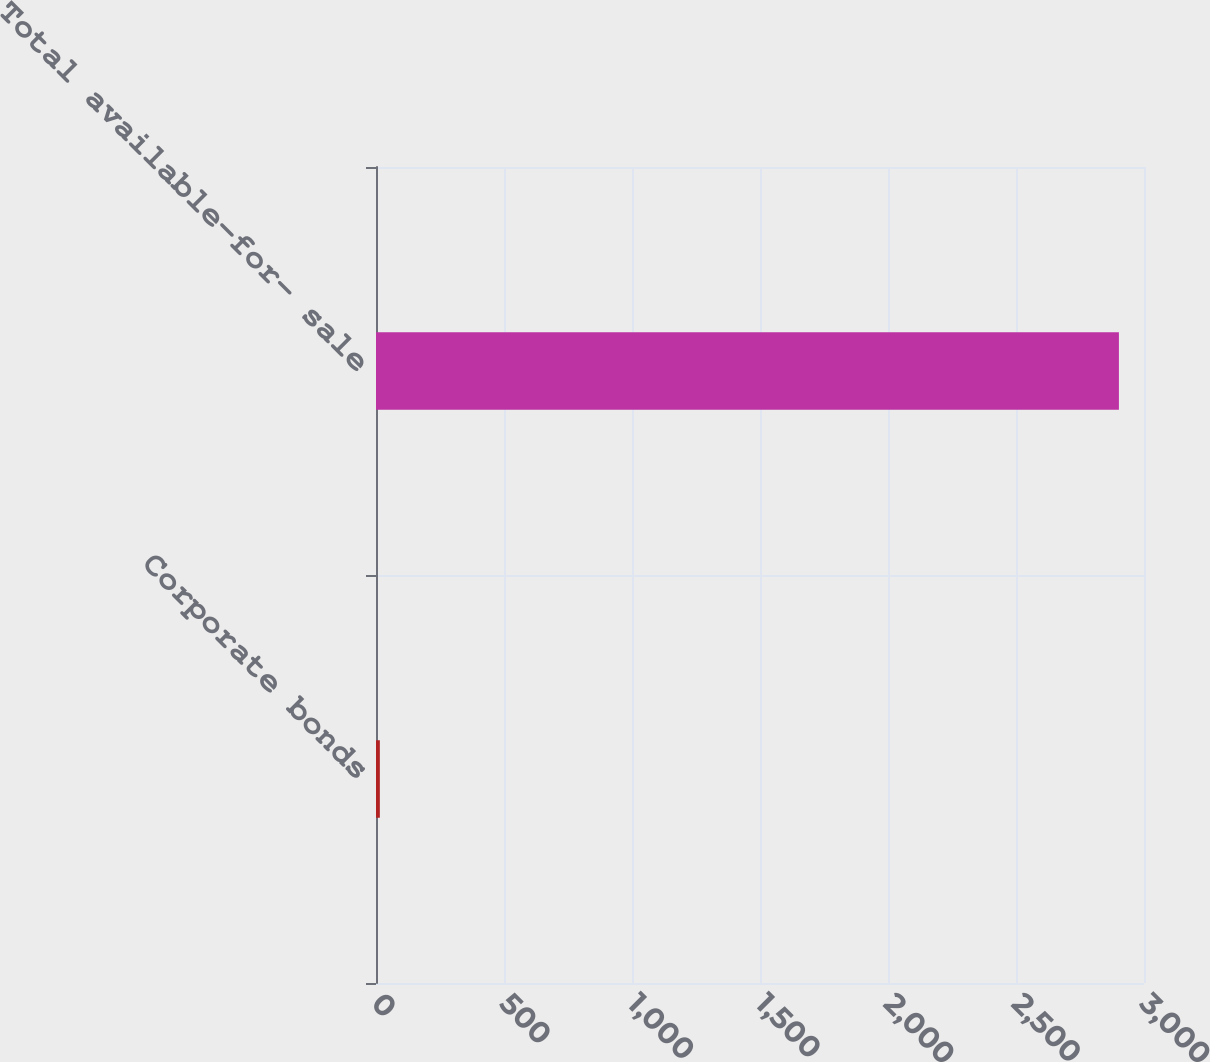<chart> <loc_0><loc_0><loc_500><loc_500><bar_chart><fcel>Corporate bonds<fcel>Total available-for- sale<nl><fcel>15<fcel>2902<nl></chart> 